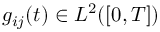<formula> <loc_0><loc_0><loc_500><loc_500>g _ { i j } ( t ) \in L ^ { 2 } ( [ 0 , T ] )</formula> 